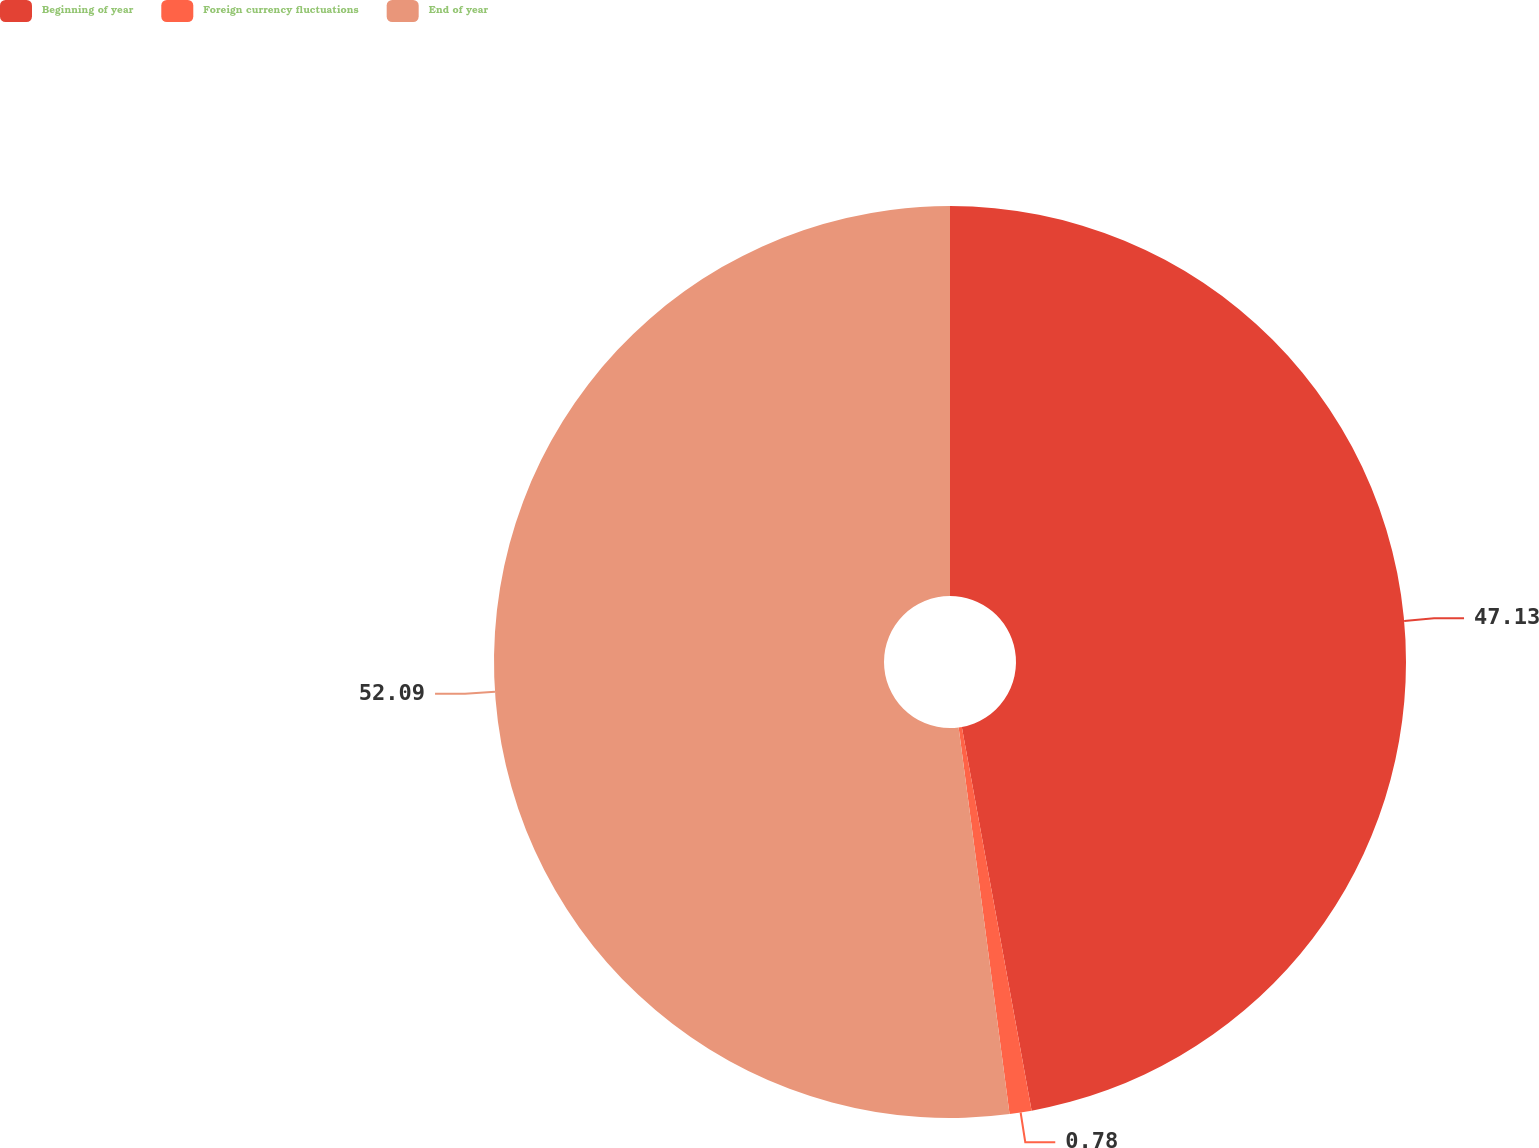Convert chart. <chart><loc_0><loc_0><loc_500><loc_500><pie_chart><fcel>Beginning of year<fcel>Foreign currency fluctuations<fcel>End of year<nl><fcel>47.13%<fcel>0.78%<fcel>52.08%<nl></chart> 